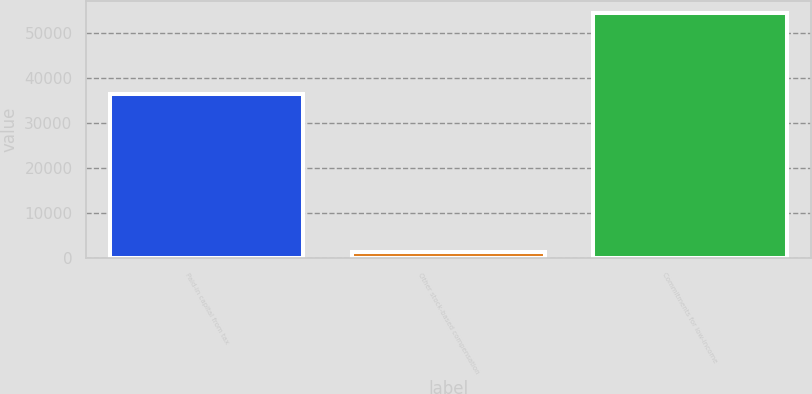Convert chart to OTSL. <chart><loc_0><loc_0><loc_500><loc_500><bar_chart><fcel>Paid-in capital from tax<fcel>Other stock-based compensation<fcel>Commitments for low-income<nl><fcel>36545<fcel>1375<fcel>54549<nl></chart> 